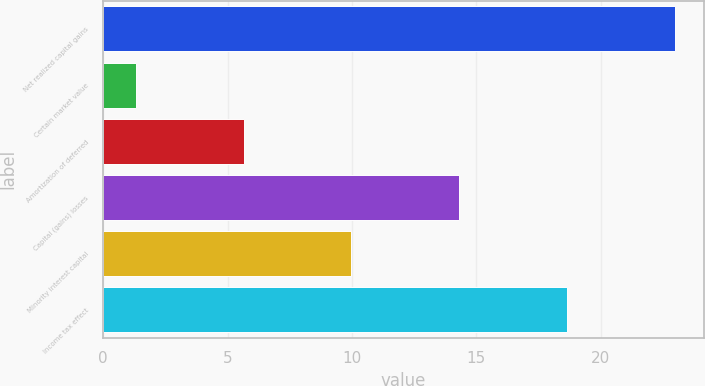Convert chart. <chart><loc_0><loc_0><loc_500><loc_500><bar_chart><fcel>Net realized capital gains<fcel>Certain market value<fcel>Amortization of deferred<fcel>Capital (gains) losses<fcel>Minority interest capital<fcel>Income tax effect<nl><fcel>23<fcel>1.3<fcel>5.64<fcel>14.32<fcel>9.98<fcel>18.66<nl></chart> 